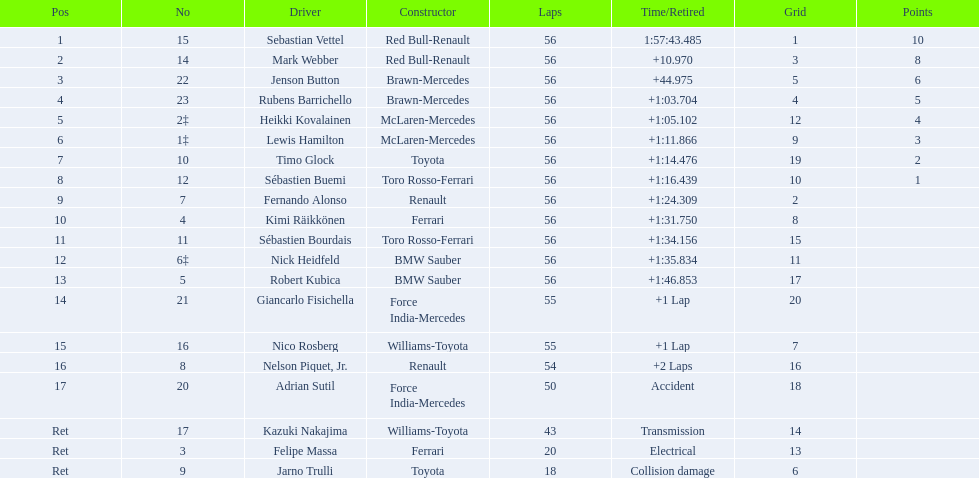Who are all the chauffeurs? Sebastian Vettel, Mark Webber, Jenson Button, Rubens Barrichello, Heikki Kovalainen, Lewis Hamilton, Timo Glock, Sébastien Buemi, Fernando Alonso, Kimi Räikkönen, Sébastien Bourdais, Nick Heidfeld, Robert Kubica, Giancarlo Fisichella, Nico Rosberg, Nelson Piquet, Jr., Adrian Sutil, Kazuki Nakajima, Felipe Massa, Jarno Trulli. Who were their fabricators? Red Bull-Renault, Red Bull-Renault, Brawn-Mercedes, Brawn-Mercedes, McLaren-Mercedes, McLaren-Mercedes, Toyota, Toro Rosso-Ferrari, Renault, Ferrari, Toro Rosso-Ferrari, BMW Sauber, BMW Sauber, Force India-Mercedes, Williams-Toyota, Renault, Force India-Mercedes, Williams-Toyota, Ferrari, Toyota. Who was the first named driver to not steer a ferrari? Sebastian Vettel. 